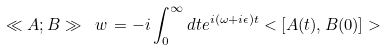Convert formula to latex. <formula><loc_0><loc_0><loc_500><loc_500>\ll A ; B \gg _ { \ } w \, = - i \int _ { 0 } ^ { \infty } d t e ^ { i ( \omega + i \epsilon ) t } < [ A ( t ) , B ( 0 ) ] ></formula> 